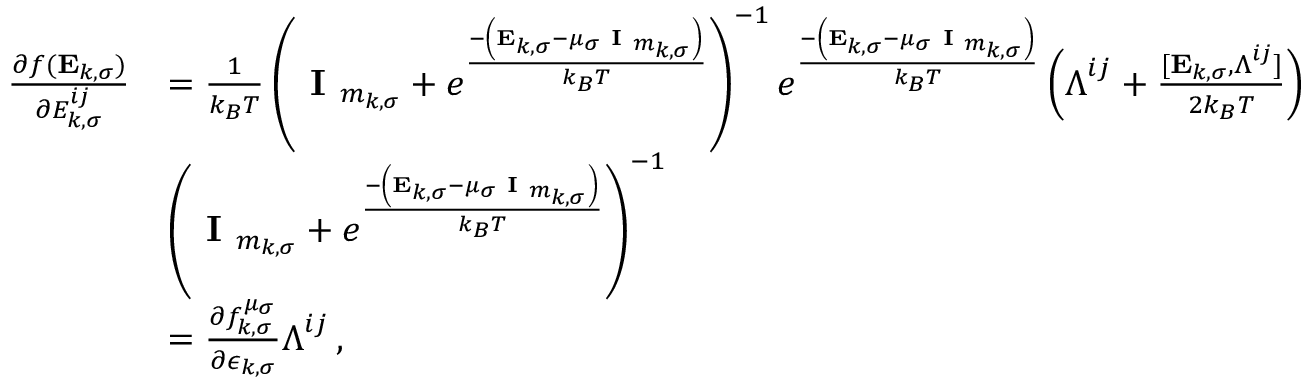<formula> <loc_0><loc_0><loc_500><loc_500>\begin{array} { r l } { \frac { \partial f ( E _ { k , \sigma } ) } { \partial { E } _ { k , \sigma } ^ { i j } } } & { = \frac { 1 } { k _ { B } T } \left ( I _ { m _ { k , \sigma } } + e ^ { \frac { - \left ( E _ { k , \sigma } - \mu _ { \sigma } I _ { m _ { k , \sigma } } \right ) } { k _ { B } T } } \right ) ^ { - 1 } e ^ { \frac { - \left ( E _ { k , \sigma } - \mu _ { \sigma } I _ { m _ { k , \sigma } } \right ) } { k _ { B } T } } \left ( \Lambda ^ { i j } + \frac { [ E _ { k , \sigma } , \Lambda ^ { i j } ] } { 2 k _ { B } T } \right ) } \\ & { \left ( I _ { m _ { k , \sigma } } + e ^ { \frac { - \left ( E _ { k , \sigma } - \mu _ { \sigma } I _ { m _ { k , \sigma } } \right ) } { k _ { B } T } } \right ) ^ { - 1 } } \\ & { = \frac { \partial f _ { k , \sigma } ^ { \mu _ { \sigma } } } { \partial \epsilon _ { k , \sigma } } \Lambda ^ { i j } \, , } \end{array}</formula> 